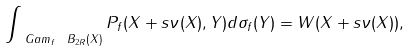Convert formula to latex. <formula><loc_0><loc_0><loc_500><loc_500>\int _ { \ G a m _ { f } \ B _ { 2 R } ( X ) } P _ { f } ( X + s \nu ( X ) , Y ) d \sigma _ { f } ( Y ) = W ( X + s \nu ( X ) ) ,</formula> 